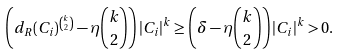<formula> <loc_0><loc_0><loc_500><loc_500>\left ( d _ { R } ( C _ { i } ) ^ { \binom { k } { 2 } } - \eta \binom { k } { 2 } \right ) | C _ { i } | ^ { k } & \geq \left ( \delta - \eta \binom { k } { 2 } \right ) | C _ { i } | ^ { k } > 0 .</formula> 